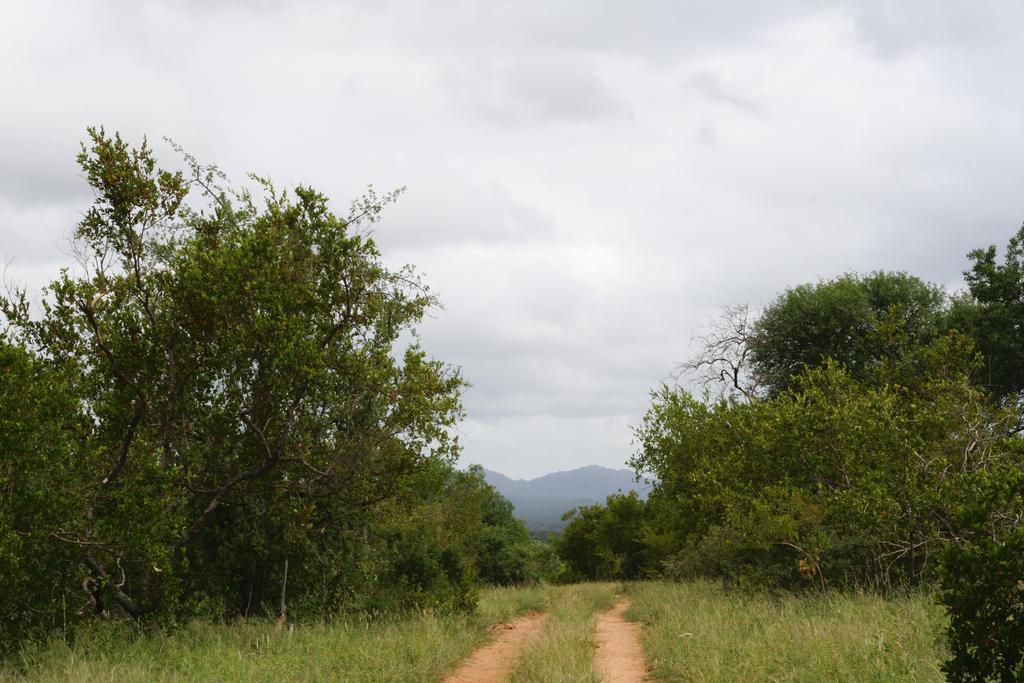Can you describe this image briefly? In this picture we can see some trees in the front. Behind there is a mountain. On the top we can see the sky and clouds. 